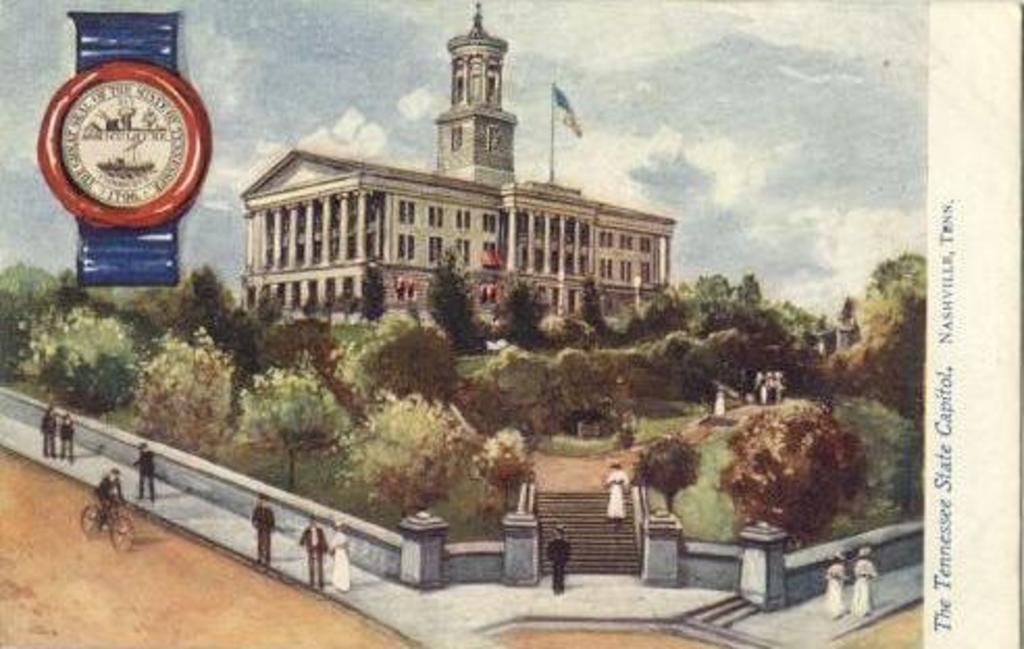Where is the photo of this card taken?
Offer a terse response. Nashville, tn. 